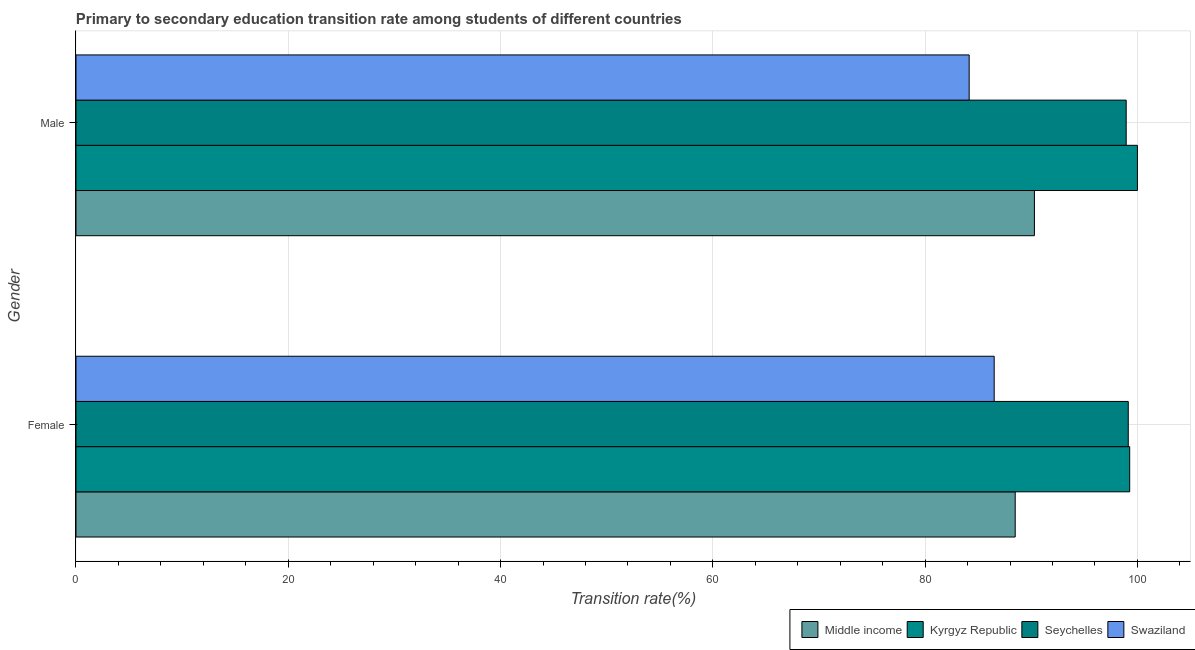How many different coloured bars are there?
Give a very brief answer. 4. Are the number of bars per tick equal to the number of legend labels?
Your answer should be compact. Yes. What is the transition rate among male students in Seychelles?
Make the answer very short. 98.94. Across all countries, what is the maximum transition rate among female students?
Make the answer very short. 99.27. Across all countries, what is the minimum transition rate among female students?
Provide a succinct answer. 86.51. In which country was the transition rate among male students maximum?
Provide a succinct answer. Kyrgyz Republic. In which country was the transition rate among female students minimum?
Keep it short and to the point. Swaziland. What is the total transition rate among female students in the graph?
Provide a short and direct response. 373.4. What is the difference between the transition rate among female students in Kyrgyz Republic and that in Seychelles?
Your answer should be compact. 0.13. What is the difference between the transition rate among male students in Kyrgyz Republic and the transition rate among female students in Seychelles?
Offer a terse response. 0.86. What is the average transition rate among male students per country?
Provide a succinct answer. 93.35. What is the difference between the transition rate among female students and transition rate among male students in Middle income?
Keep it short and to the point. -1.81. What is the ratio of the transition rate among male students in Seychelles to that in Swaziland?
Provide a short and direct response. 1.18. Is the transition rate among male students in Kyrgyz Republic less than that in Middle income?
Ensure brevity in your answer.  No. In how many countries, is the transition rate among male students greater than the average transition rate among male students taken over all countries?
Give a very brief answer. 2. What does the 1st bar from the top in Female represents?
Make the answer very short. Swaziland. What does the 4th bar from the bottom in Male represents?
Provide a succinct answer. Swaziland. How many bars are there?
Give a very brief answer. 8. What is the difference between two consecutive major ticks on the X-axis?
Keep it short and to the point. 20. Are the values on the major ticks of X-axis written in scientific E-notation?
Your response must be concise. No. Does the graph contain any zero values?
Provide a succinct answer. No. Does the graph contain grids?
Provide a short and direct response. Yes. Where does the legend appear in the graph?
Provide a short and direct response. Bottom right. How are the legend labels stacked?
Your response must be concise. Horizontal. What is the title of the graph?
Ensure brevity in your answer.  Primary to secondary education transition rate among students of different countries. Does "North America" appear as one of the legend labels in the graph?
Your response must be concise. No. What is the label or title of the X-axis?
Make the answer very short. Transition rate(%). What is the label or title of the Y-axis?
Ensure brevity in your answer.  Gender. What is the Transition rate(%) of Middle income in Female?
Offer a terse response. 88.49. What is the Transition rate(%) of Kyrgyz Republic in Female?
Ensure brevity in your answer.  99.27. What is the Transition rate(%) of Seychelles in Female?
Your answer should be compact. 99.14. What is the Transition rate(%) in Swaziland in Female?
Ensure brevity in your answer.  86.51. What is the Transition rate(%) in Middle income in Male?
Your response must be concise. 90.3. What is the Transition rate(%) in Kyrgyz Republic in Male?
Provide a succinct answer. 100. What is the Transition rate(%) in Seychelles in Male?
Provide a short and direct response. 98.94. What is the Transition rate(%) of Swaziland in Male?
Your response must be concise. 84.15. Across all Gender, what is the maximum Transition rate(%) of Middle income?
Provide a short and direct response. 90.3. Across all Gender, what is the maximum Transition rate(%) in Kyrgyz Republic?
Provide a short and direct response. 100. Across all Gender, what is the maximum Transition rate(%) in Seychelles?
Offer a very short reply. 99.14. Across all Gender, what is the maximum Transition rate(%) of Swaziland?
Give a very brief answer. 86.51. Across all Gender, what is the minimum Transition rate(%) in Middle income?
Keep it short and to the point. 88.49. Across all Gender, what is the minimum Transition rate(%) in Kyrgyz Republic?
Provide a short and direct response. 99.27. Across all Gender, what is the minimum Transition rate(%) of Seychelles?
Offer a very short reply. 98.94. Across all Gender, what is the minimum Transition rate(%) in Swaziland?
Offer a very short reply. 84.15. What is the total Transition rate(%) in Middle income in the graph?
Your answer should be compact. 178.78. What is the total Transition rate(%) in Kyrgyz Republic in the graph?
Provide a succinct answer. 199.27. What is the total Transition rate(%) in Seychelles in the graph?
Keep it short and to the point. 198.08. What is the total Transition rate(%) in Swaziland in the graph?
Provide a short and direct response. 170.66. What is the difference between the Transition rate(%) of Middle income in Female and that in Male?
Your response must be concise. -1.81. What is the difference between the Transition rate(%) of Kyrgyz Republic in Female and that in Male?
Offer a terse response. -0.73. What is the difference between the Transition rate(%) in Seychelles in Female and that in Male?
Provide a succinct answer. 0.2. What is the difference between the Transition rate(%) of Swaziland in Female and that in Male?
Make the answer very short. 2.36. What is the difference between the Transition rate(%) of Middle income in Female and the Transition rate(%) of Kyrgyz Republic in Male?
Your response must be concise. -11.51. What is the difference between the Transition rate(%) in Middle income in Female and the Transition rate(%) in Seychelles in Male?
Keep it short and to the point. -10.46. What is the difference between the Transition rate(%) in Middle income in Female and the Transition rate(%) in Swaziland in Male?
Your answer should be very brief. 4.34. What is the difference between the Transition rate(%) of Kyrgyz Republic in Female and the Transition rate(%) of Seychelles in Male?
Your response must be concise. 0.33. What is the difference between the Transition rate(%) in Kyrgyz Republic in Female and the Transition rate(%) in Swaziland in Male?
Keep it short and to the point. 15.12. What is the difference between the Transition rate(%) in Seychelles in Female and the Transition rate(%) in Swaziland in Male?
Your answer should be very brief. 14.99. What is the average Transition rate(%) of Middle income per Gender?
Your response must be concise. 89.39. What is the average Transition rate(%) in Kyrgyz Republic per Gender?
Provide a succinct answer. 99.64. What is the average Transition rate(%) in Seychelles per Gender?
Offer a terse response. 99.04. What is the average Transition rate(%) in Swaziland per Gender?
Your response must be concise. 85.33. What is the difference between the Transition rate(%) in Middle income and Transition rate(%) in Kyrgyz Republic in Female?
Ensure brevity in your answer.  -10.79. What is the difference between the Transition rate(%) of Middle income and Transition rate(%) of Seychelles in Female?
Make the answer very short. -10.65. What is the difference between the Transition rate(%) of Middle income and Transition rate(%) of Swaziland in Female?
Offer a terse response. 1.98. What is the difference between the Transition rate(%) of Kyrgyz Republic and Transition rate(%) of Seychelles in Female?
Provide a short and direct response. 0.13. What is the difference between the Transition rate(%) in Kyrgyz Republic and Transition rate(%) in Swaziland in Female?
Your answer should be very brief. 12.77. What is the difference between the Transition rate(%) in Seychelles and Transition rate(%) in Swaziland in Female?
Your response must be concise. 12.63. What is the difference between the Transition rate(%) of Middle income and Transition rate(%) of Kyrgyz Republic in Male?
Your answer should be compact. -9.7. What is the difference between the Transition rate(%) of Middle income and Transition rate(%) of Seychelles in Male?
Offer a terse response. -8.65. What is the difference between the Transition rate(%) of Middle income and Transition rate(%) of Swaziland in Male?
Provide a short and direct response. 6.15. What is the difference between the Transition rate(%) of Kyrgyz Republic and Transition rate(%) of Seychelles in Male?
Make the answer very short. 1.06. What is the difference between the Transition rate(%) in Kyrgyz Republic and Transition rate(%) in Swaziland in Male?
Make the answer very short. 15.85. What is the difference between the Transition rate(%) of Seychelles and Transition rate(%) of Swaziland in Male?
Ensure brevity in your answer.  14.79. What is the ratio of the Transition rate(%) in Swaziland in Female to that in Male?
Offer a very short reply. 1.03. What is the difference between the highest and the second highest Transition rate(%) in Middle income?
Make the answer very short. 1.81. What is the difference between the highest and the second highest Transition rate(%) of Kyrgyz Republic?
Keep it short and to the point. 0.73. What is the difference between the highest and the second highest Transition rate(%) of Seychelles?
Keep it short and to the point. 0.2. What is the difference between the highest and the second highest Transition rate(%) of Swaziland?
Offer a terse response. 2.36. What is the difference between the highest and the lowest Transition rate(%) of Middle income?
Your response must be concise. 1.81. What is the difference between the highest and the lowest Transition rate(%) of Kyrgyz Republic?
Offer a very short reply. 0.73. What is the difference between the highest and the lowest Transition rate(%) of Seychelles?
Ensure brevity in your answer.  0.2. What is the difference between the highest and the lowest Transition rate(%) of Swaziland?
Your answer should be very brief. 2.36. 